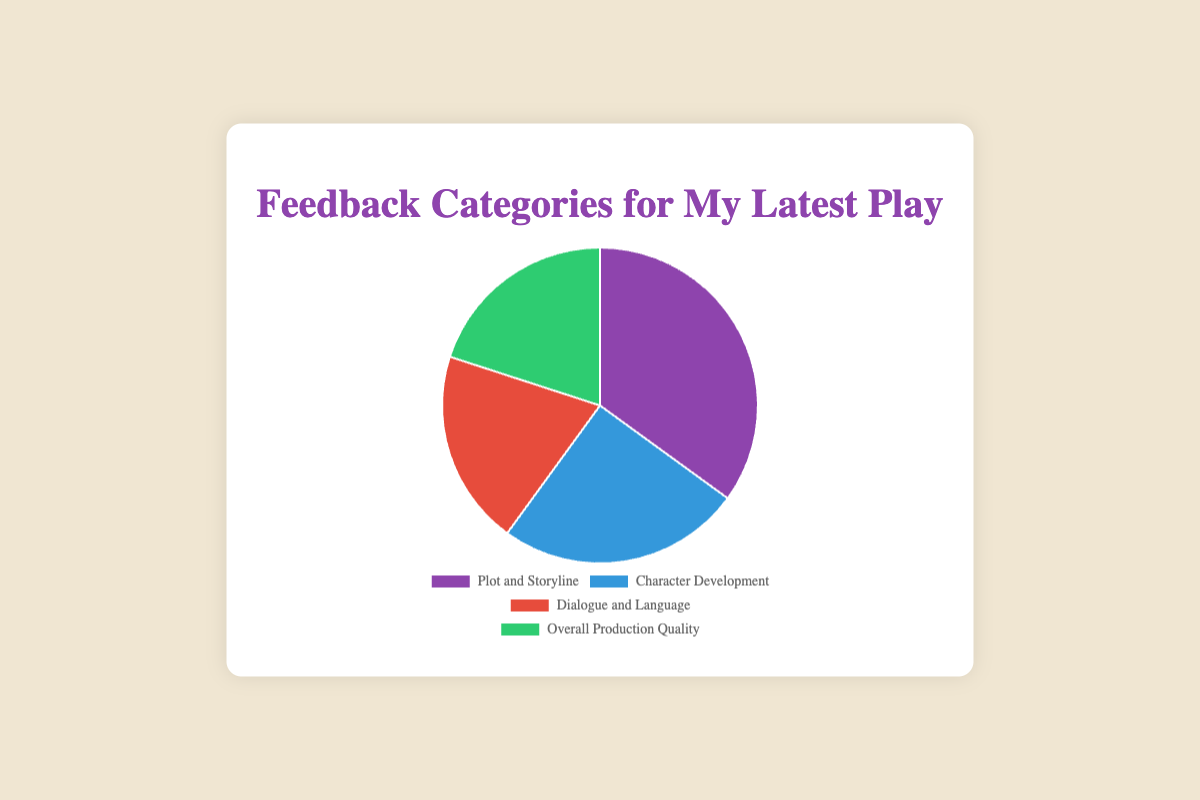What percentage of the total feedback is about Dialogue and Language? Look at the slice labeled "Dialogue and Language" in the pie chart; its value is 20. Since each category shows its percentage directly, the "Dialogue and Language" feedback has a 20% share of the total.
Answer: 20% Which feedback category has the highest percentage? Look for the largest slice in the pie chart, which represents "Plot and Storyline" with 35%.
Answer: Plot and Storyline How do Plot and Storyline compare to Character Development in terms of percentage? Compare the numbers in the slices: Plot and Storyline is 35%, and Character Development is 25%. Since 35% is greater than 25%, Plot and Storyline have a higher percentage.
Answer: Plot and Storyline has 10% more What is the sum of percentages for categories that are not Plot and Storyline? Add the percentages of "Character Development" (25%), "Dialogue and Language" (20%), and "Overall Production Quality" (20%). The sum is 25 + 20 + 20 = 65%.
Answer: 65% What is the average feedback percentage across all categories? Add all category percentages: 35 + 25 + 20 + 20 = 100. Then, divide by the number of categories: 100 ÷ 4 = 25%.
Answer: 25% What is the difference in percentage between the smallest category and the largest category? The largest category is "Plot and Storyline" with 35%, and the smallest categories are "Dialogue and Language" and "Overall Production Quality," both at 20%. The difference is 35 - 20 = 15%.
Answer: 15% Which category has the same percentage as Dialogue and Language? Look for the slice with the same percentage as "Dialogue and Language," which is 20%. "Overall Production Quality" also has 20%.
Answer: Overall Production Quality What is the total percentage of feedback for Character Development and Dialogue and Language combined? Add the percentages of "Character Development" (25%) and "Dialogue and Language" (20%), giving 25 + 20 = 45%.
Answer: 45% Which slice is colored green in the pie chart? Identify the slice that is colored green by scanning the visual: "Overall Production Quality" has the green color.
Answer: Overall Production Quality 